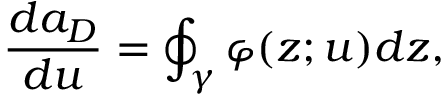<formula> <loc_0><loc_0><loc_500><loc_500>\frac { d a _ { D } } { d u } = \oint _ { \gamma } \varphi ( z ; u ) d z ,</formula> 